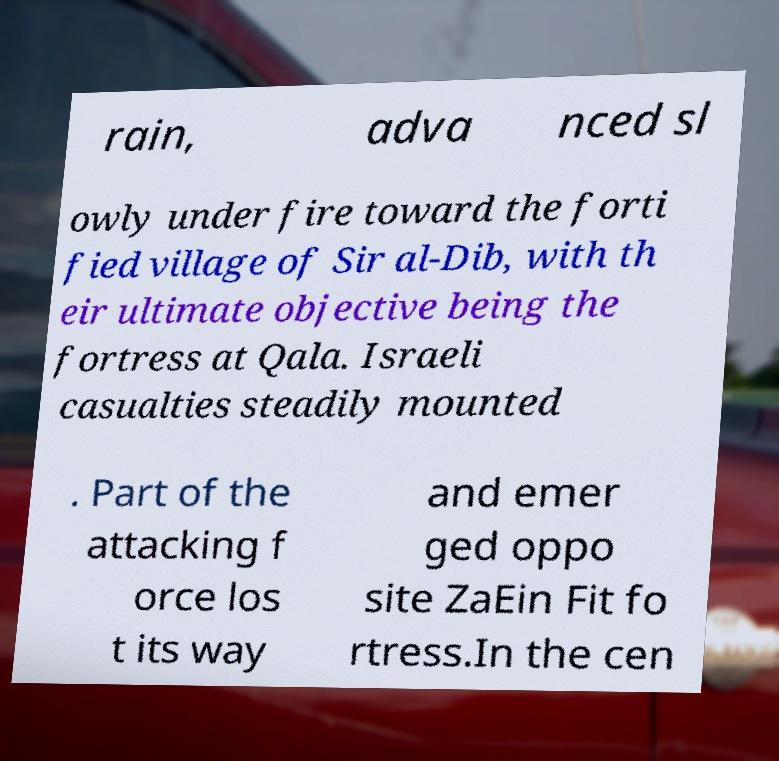Please read and relay the text visible in this image. What does it say? rain, adva nced sl owly under fire toward the forti fied village of Sir al-Dib, with th eir ultimate objective being the fortress at Qala. Israeli casualties steadily mounted . Part of the attacking f orce los t its way and emer ged oppo site ZaEin Fit fo rtress.In the cen 